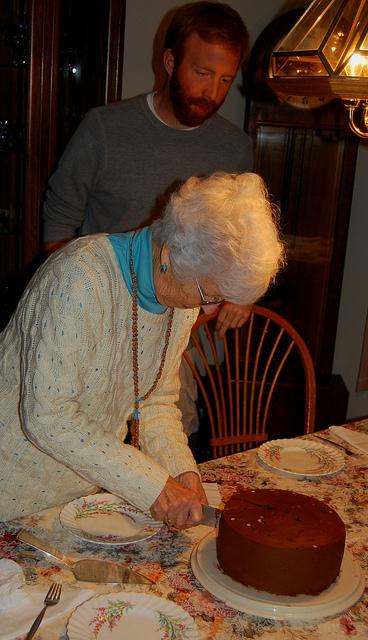What is mainly featured?
Concise answer only. Cake. What is the woman cutting the cake with?
Quick response, please. Knife. Is the cake a round cake?
Quick response, please. Yes. What color is the man's shirt?
Give a very brief answer. Gray. What color is the frosting?
Be succinct. Brown. What is he eating?
Answer briefly. Cake. What kind of food is in front of him?
Short answer required. Cake. 